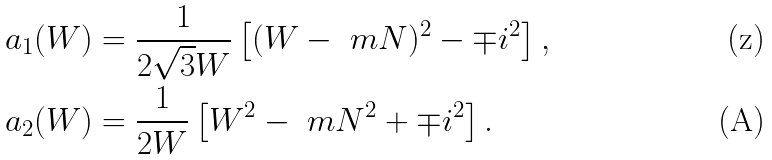<formula> <loc_0><loc_0><loc_500><loc_500>a _ { 1 } ( W ) & = \frac { 1 } { 2 \sqrt { 3 } W } \left [ ( W - \ m N ) ^ { 2 } - \mp i ^ { 2 } \right ] , \\ a _ { 2 } ( W ) & = \frac { 1 } { 2 W } \left [ W ^ { 2 } - \ m N ^ { 2 } + \mp i ^ { 2 } \right ] .</formula> 